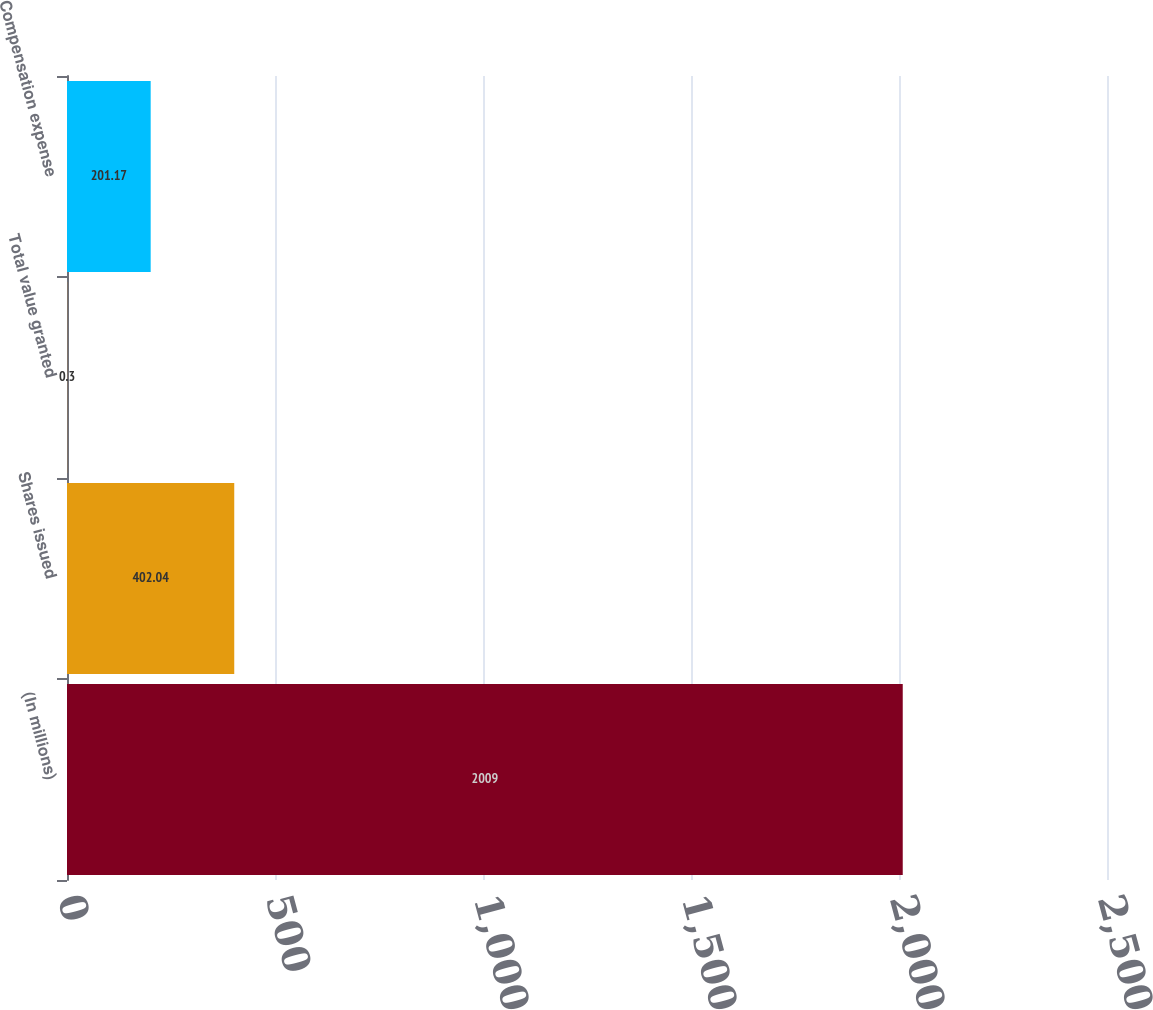Convert chart. <chart><loc_0><loc_0><loc_500><loc_500><bar_chart><fcel>(In millions)<fcel>Shares issued<fcel>Total value granted<fcel>Compensation expense<nl><fcel>2009<fcel>402.04<fcel>0.3<fcel>201.17<nl></chart> 